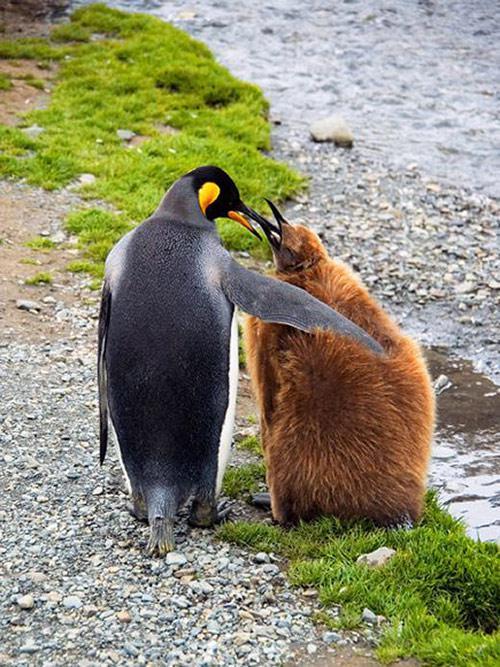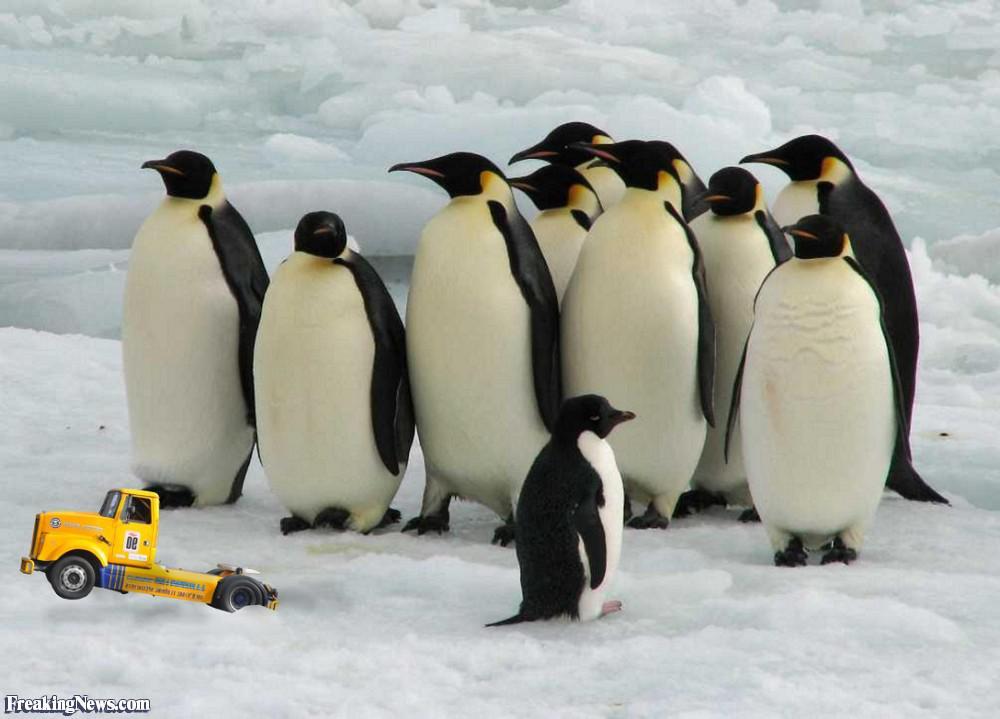The first image is the image on the left, the second image is the image on the right. For the images shown, is this caption "An image shows penguin parents with beaks pointed down toward their offspring." true? Answer yes or no. No. 